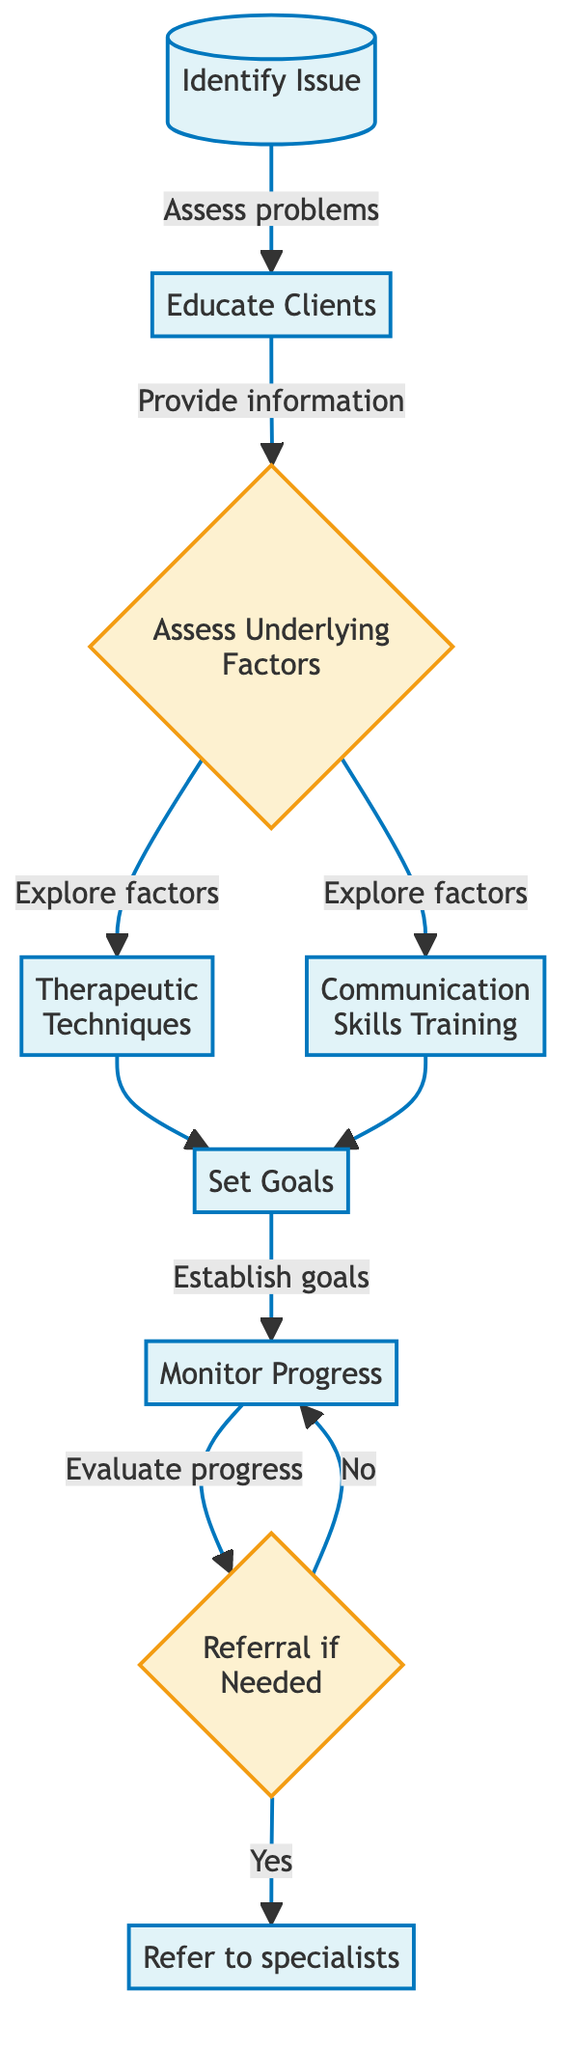What is the first step in the therapy pathway? The first step is labeled "Identify Issue", which assesses individual or couple's sexual problems.
Answer: Identify Issue How many main processes are there in total? Counting the process nodes presented in the diagram yields a total of five main processes: Identify Issue, Educate Clients, Therapeutic Techniques, Communication Skills Training, and Monitor Progress.
Answer: Five What does "Assess Underlying Factors" lead to? "Assess Underlying Factors" leads to two processes: "Therapeutic Techniques" and "Communication Skills Training", allowing exploration of factors related to both.
Answer: Therapeutic Techniques and Communication Skills Training What do clients collaborate on after understanding their issues? After understanding their issues, clients collaborate on "Set Goals" to establish realistic sexual health goals based on their needs.
Answer: Set Goals If a referral is necessary, which step follows? If a referral is necessary, the next step is to "Refer to specialists," which is indicated by the node connected to the "Referral if Needed" decision node.
Answer: Refer to specialists How do clients receive education in the therapy pathway? Clients receive education by moving from "Identify Issue" to "Educate Clients," a direct link in the therapy pathway indicating that education follows issue identification.
Answer: Educate Clients What happens if a referral is not needed? If a referral is not needed, clients continue to "Monitor Progress," as indicated by the loop back to this step from the "Referral if Needed" decision.
Answer: Monitor Progress What is the output if issues are assessed and no referral is necessary? If issues are assessed and no referral is necessary, clients will proceed to "Monitor Progress," thereby continuously evaluating their progress towards established goals.
Answer: Monitor Progress Which therapeutic technique is mentioned in the diagram? The diagram mentions "Cognitive-Behavioral Therapy (CBT)" as one of the therapeutic techniques used in treatment.
Answer: Cognitive-Behavioral Therapy (CBT) 